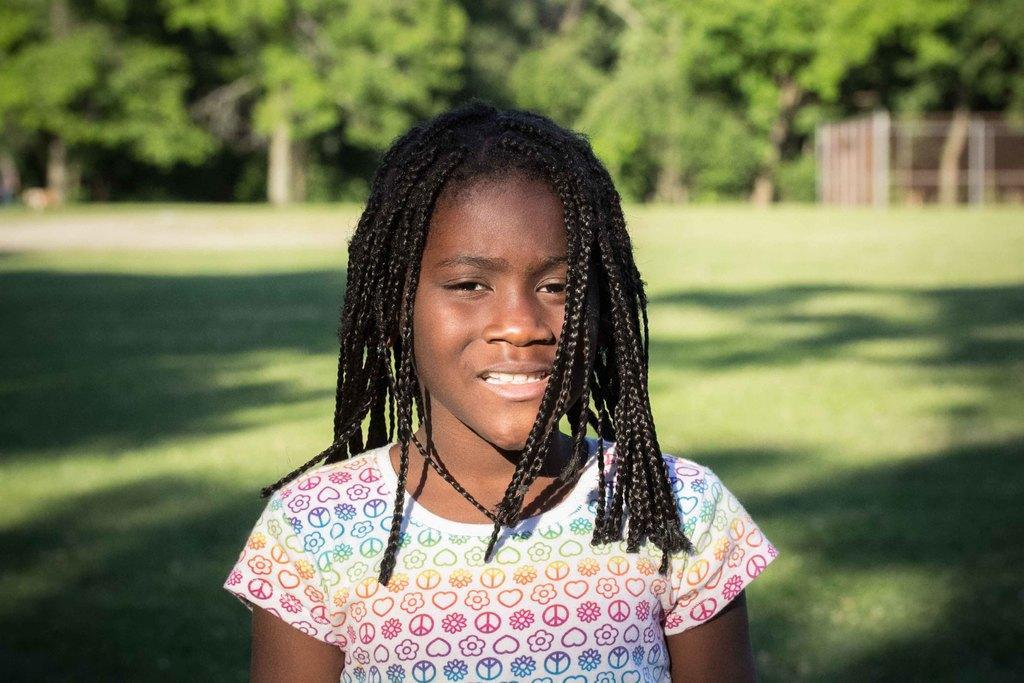Can you describe this image briefly? In this image we can see a girl standing on the grass field. In the background, we can see a group of trees and some poles. 